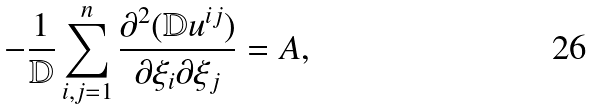<formula> <loc_0><loc_0><loc_500><loc_500>- \frac { 1 } { \mathbb { D } } \sum _ { i , j = 1 } ^ { n } \frac { \partial ^ { 2 } ( \mathbb { D } u ^ { i j } ) } { \partial \xi _ { i } \partial \xi _ { j } } = A ,</formula> 